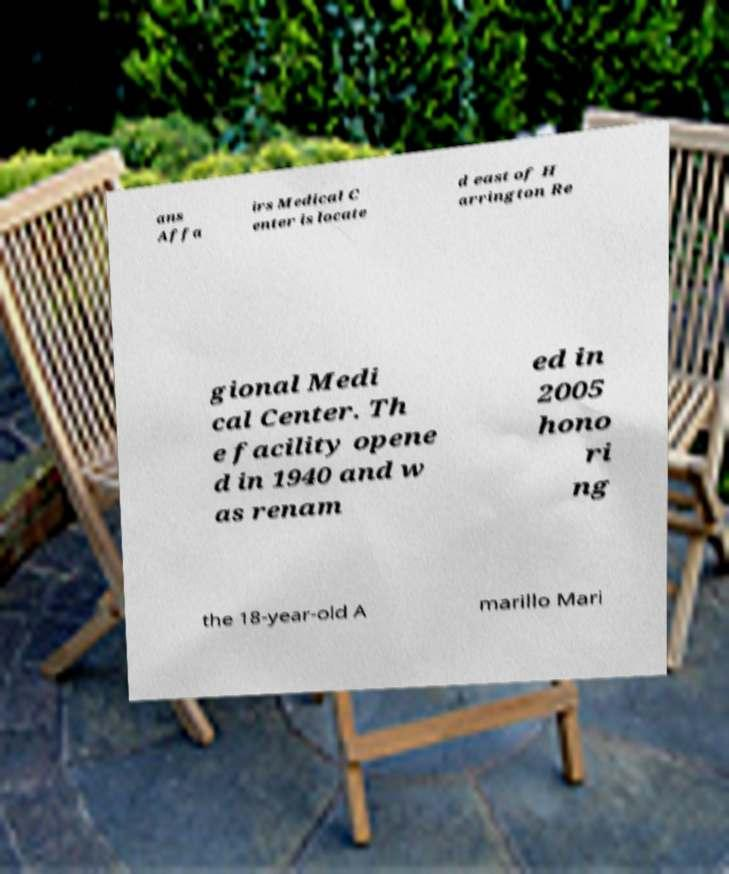Can you accurately transcribe the text from the provided image for me? ans Affa irs Medical C enter is locate d east of H arrington Re gional Medi cal Center. Th e facility opene d in 1940 and w as renam ed in 2005 hono ri ng the 18-year-old A marillo Mari 